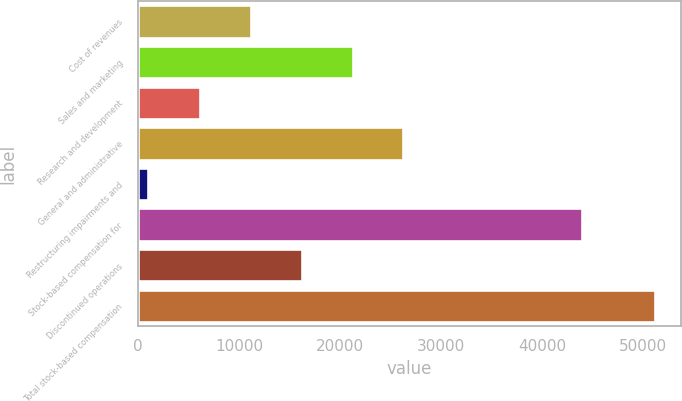Convert chart. <chart><loc_0><loc_0><loc_500><loc_500><bar_chart><fcel>Cost of revenues<fcel>Sales and marketing<fcel>Research and development<fcel>General and administrative<fcel>Restructuring impairments and<fcel>Stock-based compensation for<fcel>Discontinued operations<fcel>Total stock-based compensation<nl><fcel>11186.8<fcel>21228.4<fcel>6166<fcel>26249.2<fcel>958<fcel>43887<fcel>16207.6<fcel>51166<nl></chart> 